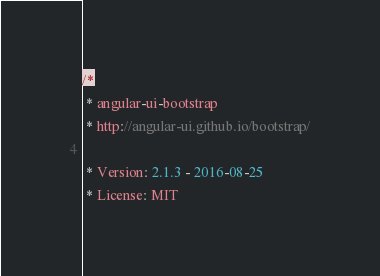<code> <loc_0><loc_0><loc_500><loc_500><_JavaScript_>/*
 * angular-ui-bootstrap
 * http://angular-ui.github.io/bootstrap/

 * Version: 2.1.3 - 2016-08-25
 * License: MIT</code> 